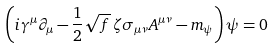<formula> <loc_0><loc_0><loc_500><loc_500>\left ( i \gamma ^ { \mu } \partial _ { \mu } - \frac { 1 } { 2 } \sqrt { f } \, \zeta \sigma _ { \mu \nu } A ^ { \mu \nu } - m _ { \psi } \right ) \psi = 0</formula> 